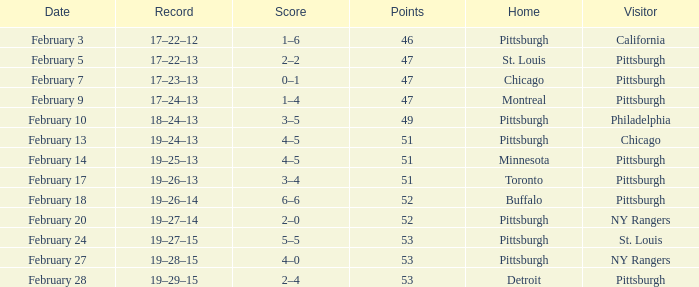Which Score has a Visitor of ny rangers, and a Record of 19–28–15? 4–0. 